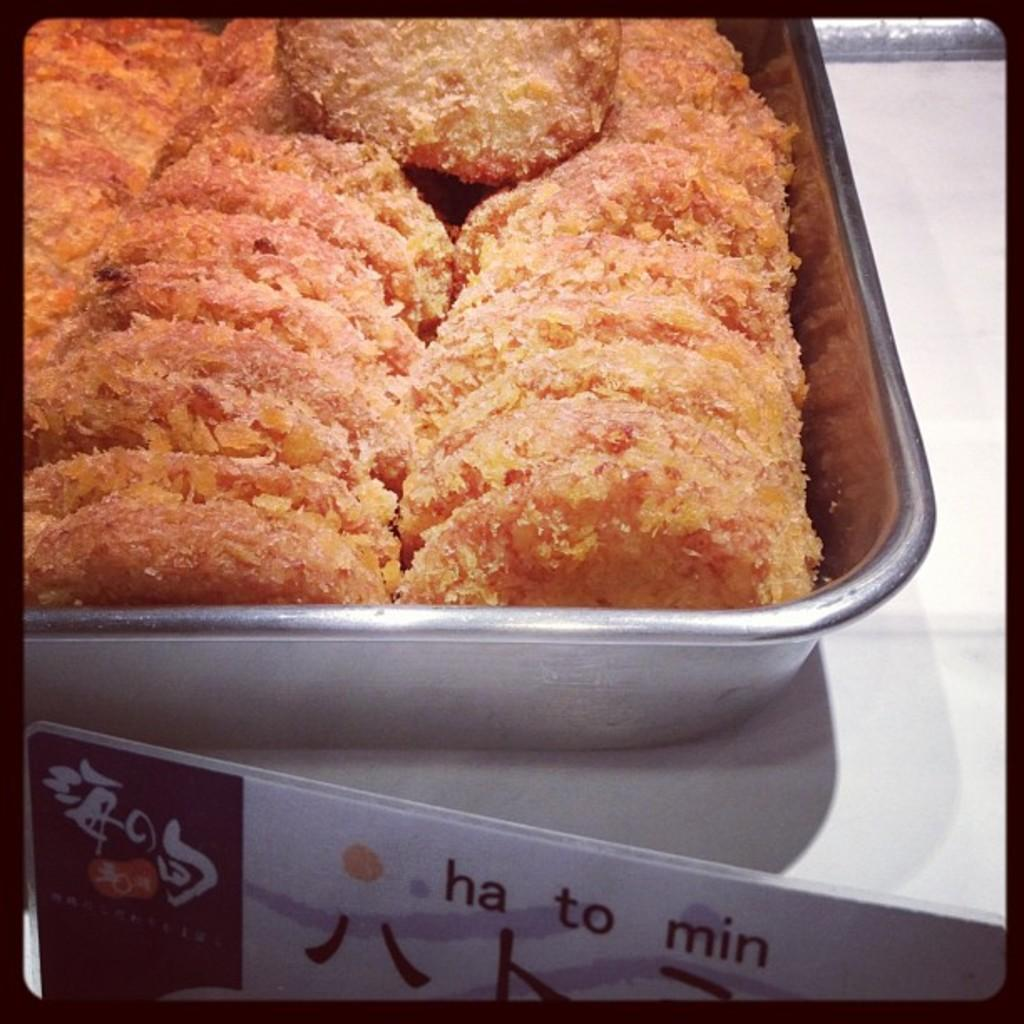What is located in the center of the image? There is a plate in the center of the image. What is on the plate? There are food items on the plate. What is at the bottom of the image? There is a board at the bottom of the image. What can be read on the board? There is text on the board. What type of juice is being served in the image? There is no juice present in the image; it only features a plate with food items and a board with text. 